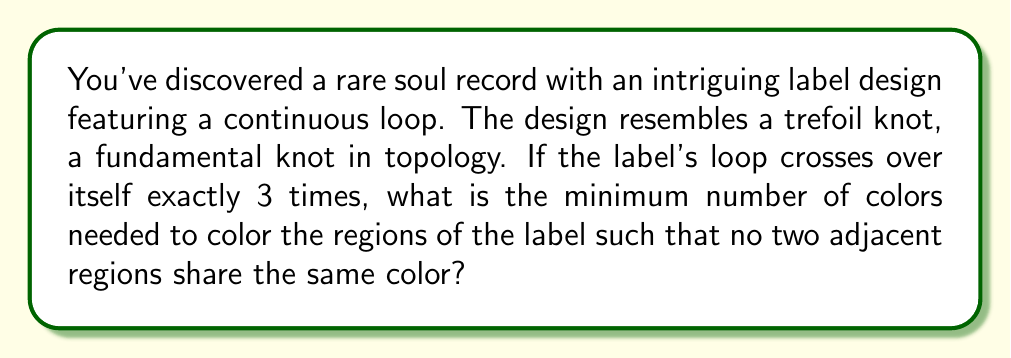Give your solution to this math problem. To solve this problem, we'll use concepts from knot theory and graph coloring:

1. Recognize that the trefoil knot, when projected onto a plane (like a record label), divides the plane into regions.

2. The number of crossings in a trefoil knot is always 3.

3. For a knot diagram with $n$ crossings, the number of regions $R$ is given by the formula:
   $$R = n + 2$$

4. In this case, with 3 crossings:
   $$R = 3 + 2 = 5$$ regions

5. The regions of a knot diagram can be colored like a map, where adjacent regions must have different colors.

6. According to the Four Color Theorem, any map on a plane can be colored using at most 4 colors.

7. However, for the trefoil knot specifically, we can prove that 3 colors are sufficient and necessary:
   - Draw the trefoil knot
   - Color the outer region (1st color)
   - Color alternating inner regions (2nd color)
   - Color the remaining regions (3rd color)

8. This coloring ensures no adjacent regions share the same color, and it's impossible to do with fewer than 3 colors due to the knot's structure.
Answer: 3 colors 